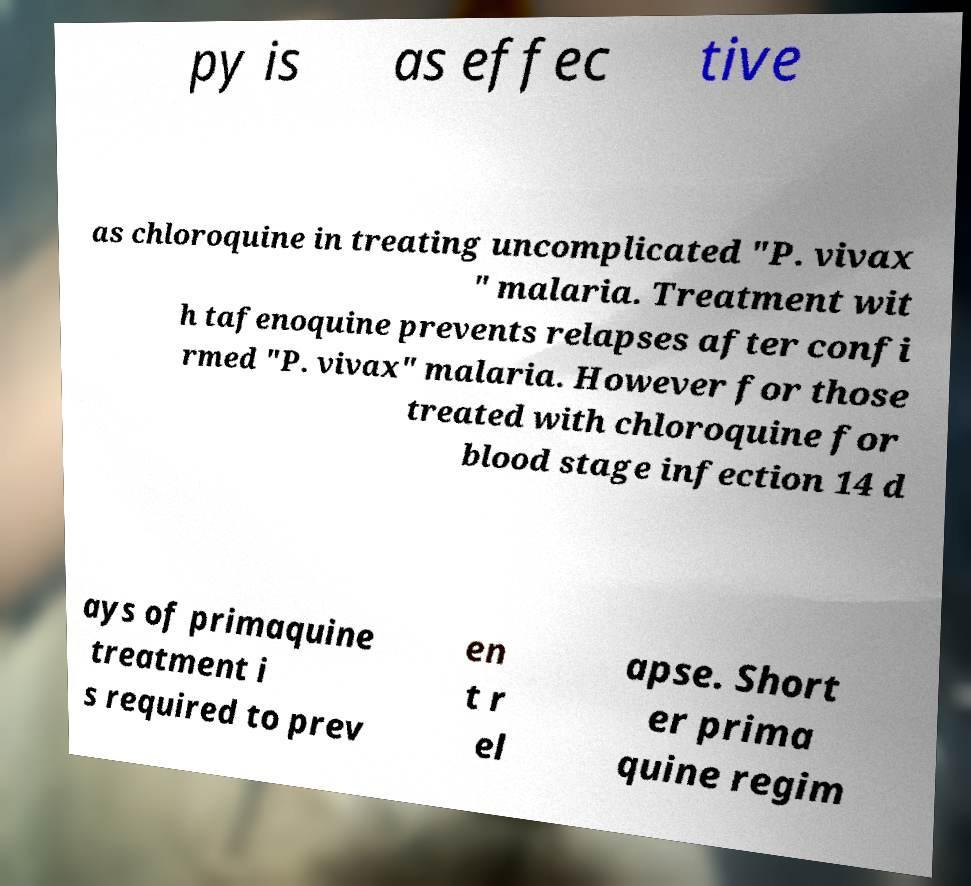Please identify and transcribe the text found in this image. py is as effec tive as chloroquine in treating uncomplicated "P. vivax " malaria. Treatment wit h tafenoquine prevents relapses after confi rmed "P. vivax" malaria. However for those treated with chloroquine for blood stage infection 14 d ays of primaquine treatment i s required to prev en t r el apse. Short er prima quine regim 